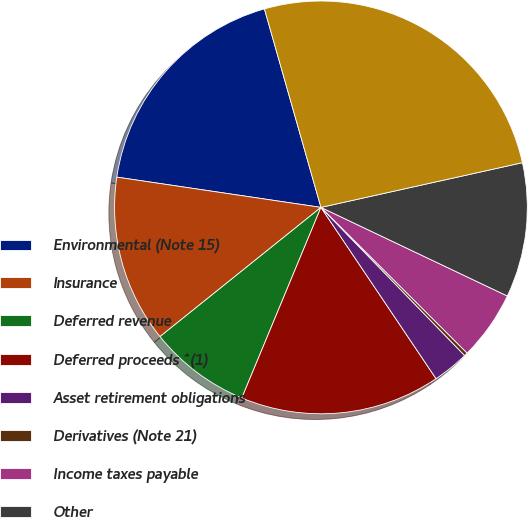<chart> <loc_0><loc_0><loc_500><loc_500><pie_chart><fcel>Environmental (Note 15)<fcel>Insurance<fcel>Deferred revenue<fcel>Deferred proceeds ^(1)<fcel>Asset retirement obligations<fcel>Derivatives (Note 21)<fcel>Income taxes payable<fcel>Other<fcel>Total<nl><fcel>18.24%<fcel>13.11%<fcel>7.97%<fcel>15.68%<fcel>2.84%<fcel>0.27%<fcel>5.41%<fcel>10.54%<fcel>25.94%<nl></chart> 